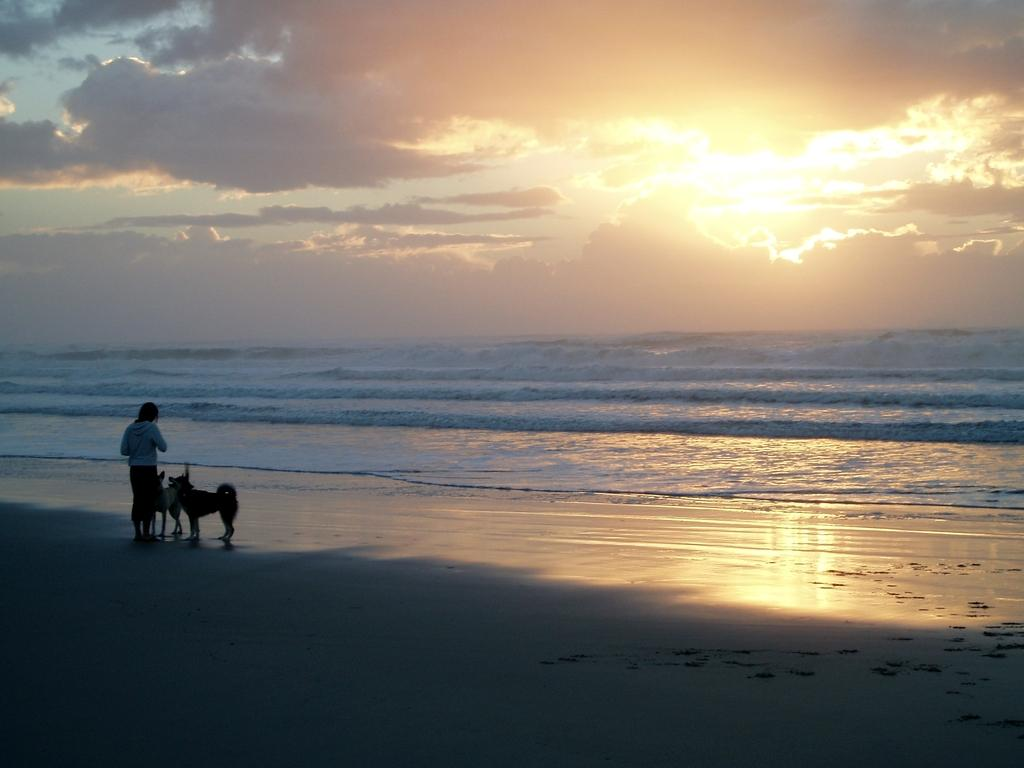Who is present in the image? There is a person in the image. What is the setting of the image? The person is standing in front of a seashore. Are there any animals in the image? Yes, there are two dogs with the person. What can be seen in the background of the image? There is a sea visible in the background of the image, and there is a beautiful sunrise in the sky. We start by identifying the main subject in the image, which is the person standing in front of the seashore. Then, we expand the conversation to include the presence of the two dogs and the beautiful sunrise in the background. Each question is designed to elicit a specific detail about the image that is known from the provided facts. Absurd Question/Answer: What type of yam is being held by the person in the image? There is no yam present in the image; the person is standing in front of a seashore with two dogs. How many branches can be seen in the image? There are no branches visible in the image; the person is standing in front of a seashore with two dogs and a beautiful sunrise in the background. 